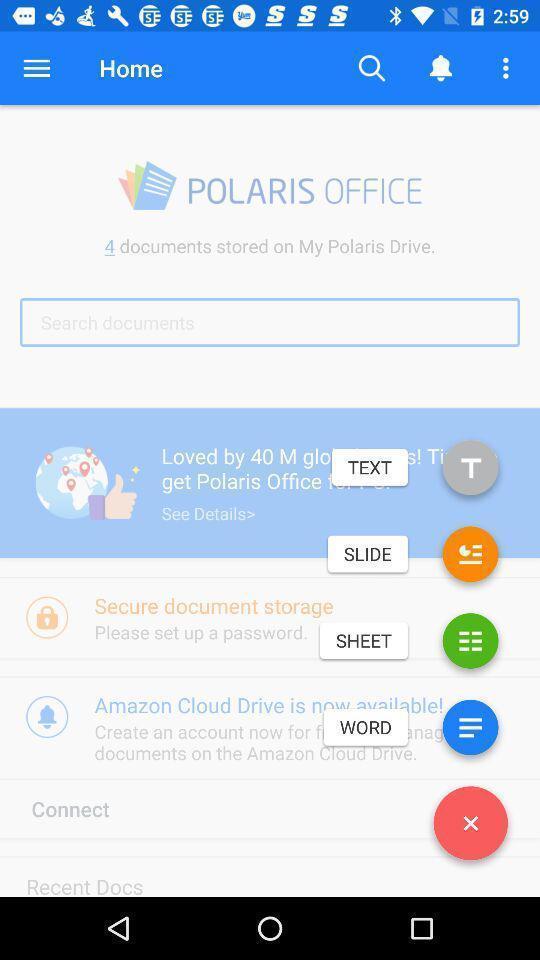Describe the content in this image. Screen shows about an android office app. 